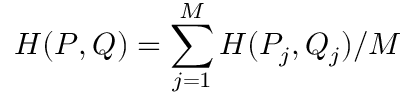Convert formula to latex. <formula><loc_0><loc_0><loc_500><loc_500>H ( P , Q ) = \sum _ { j = 1 } ^ { M } H ( P _ { j } , Q _ { j } ) / M</formula> 